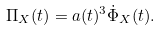Convert formula to latex. <formula><loc_0><loc_0><loc_500><loc_500>\Pi _ { X } ( t ) = a ( t ) ^ { 3 } \dot { \Phi } _ { X } ( t ) .</formula> 